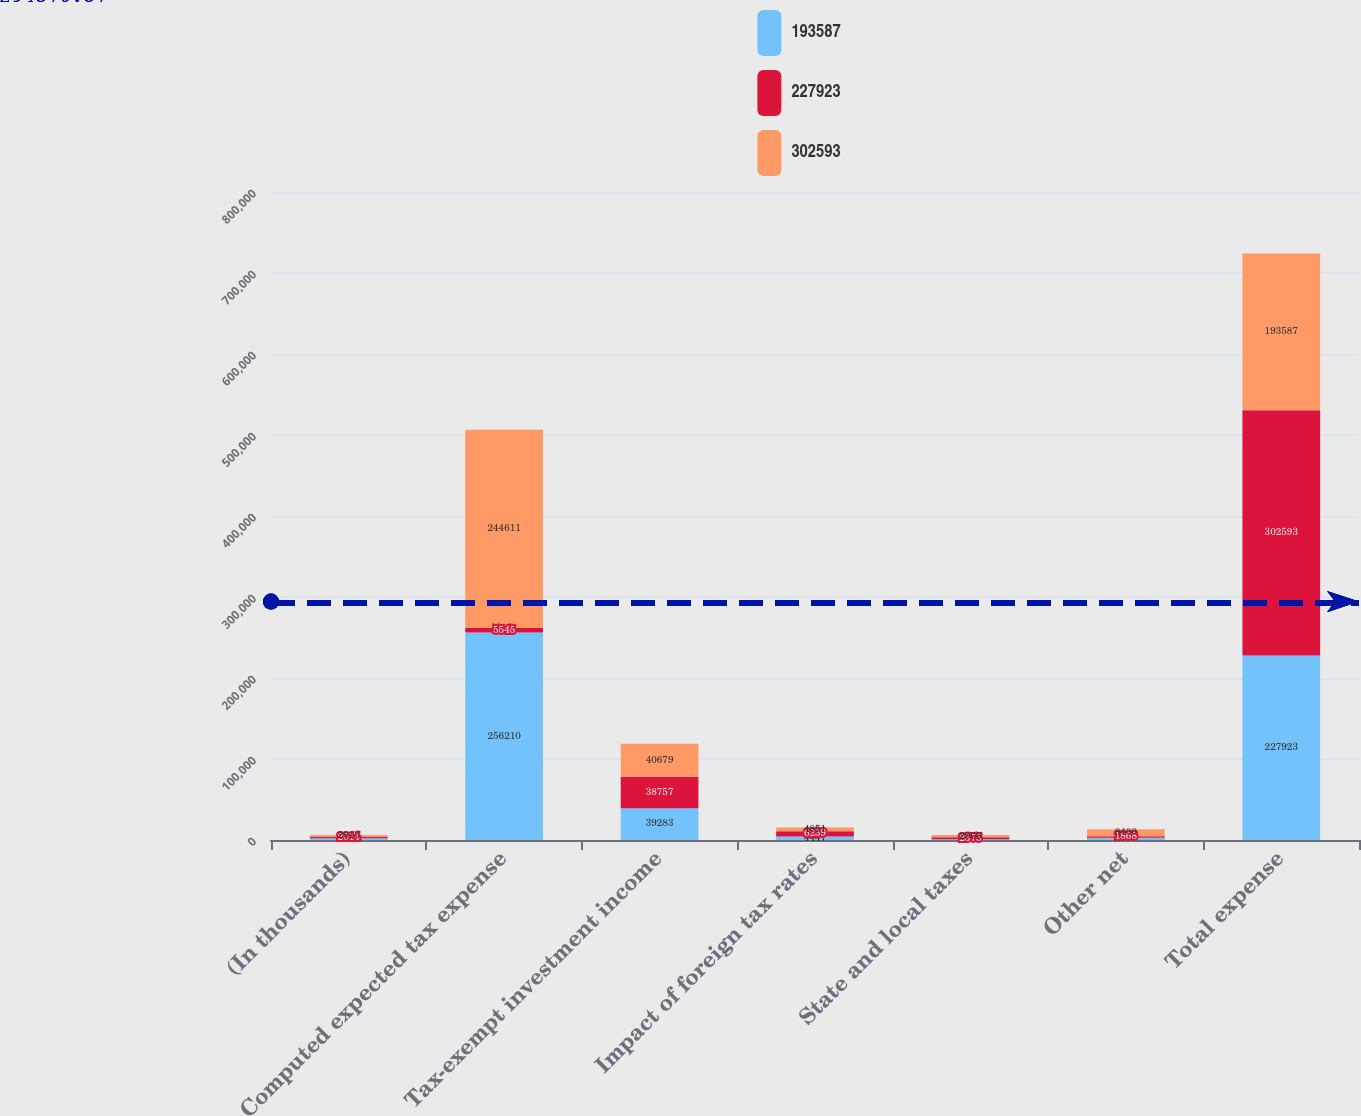<chart> <loc_0><loc_0><loc_500><loc_500><stacked_bar_chart><ecel><fcel>(In thousands)<fcel>Computed expected tax expense<fcel>Tax-exempt investment income<fcel>Impact of foreign tax rates<fcel>State and local taxes<fcel>Other net<fcel>Total expense<nl><fcel>193587<fcel>2015<fcel>256210<fcel>39283<fcel>4447<fcel>940<fcel>2907<fcel>227923<nl><fcel>227923<fcel>2014<fcel>5545<fcel>38757<fcel>6239<fcel>2375<fcel>1868<fcel>302593<nl><fcel>302593<fcel>2013<fcel>244611<fcel>40679<fcel>4851<fcel>2906<fcel>8400<fcel>193587<nl></chart> 